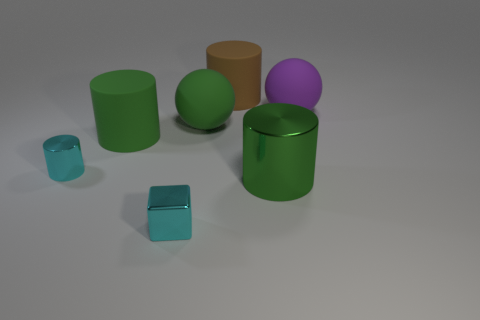How many green cylinders must be subtracted to get 1 green cylinders? 1 Subtract 1 cylinders. How many cylinders are left? 3 Subtract all tiny metal cylinders. How many cylinders are left? 3 Subtract 0 red blocks. How many objects are left? 7 Subtract all balls. How many objects are left? 5 Subtract all blue cylinders. Subtract all yellow cubes. How many cylinders are left? 4 Subtract all brown balls. How many cyan cylinders are left? 1 Subtract all purple matte balls. Subtract all metallic objects. How many objects are left? 3 Add 4 cyan metal cylinders. How many cyan metal cylinders are left? 5 Add 2 large brown metal cylinders. How many large brown metal cylinders exist? 2 